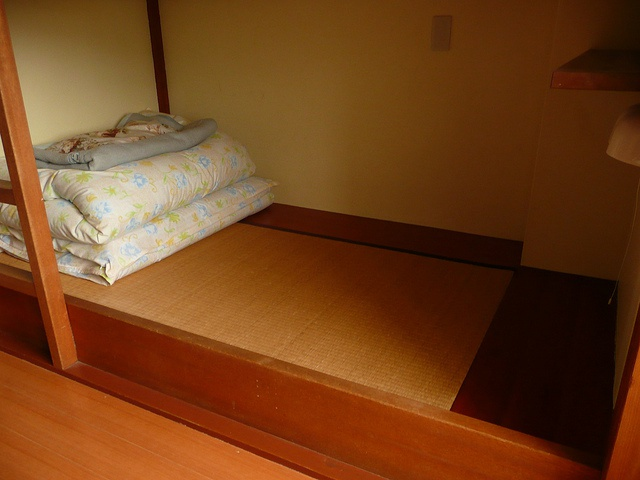Describe the objects in this image and their specific colors. I can see a bed in maroon, black, brown, and tan tones in this image. 